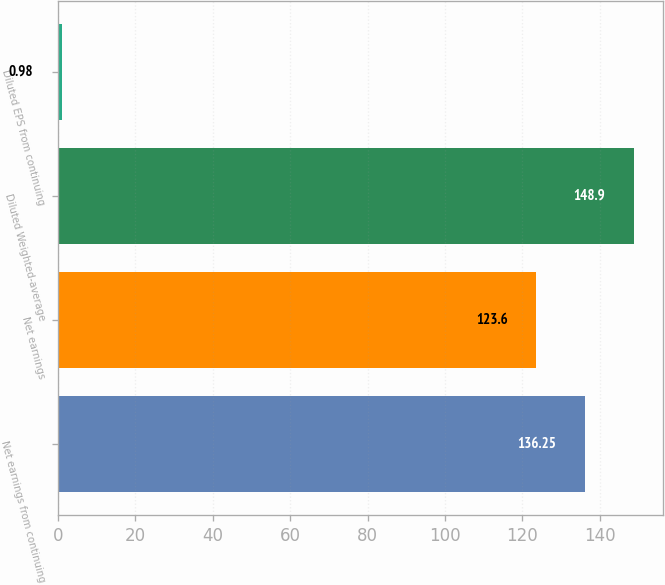<chart> <loc_0><loc_0><loc_500><loc_500><bar_chart><fcel>Net earnings from continuing<fcel>Net earnings<fcel>Diluted Weighted-average<fcel>Diluted EPS from continuing<nl><fcel>136.25<fcel>123.6<fcel>148.9<fcel>0.98<nl></chart> 